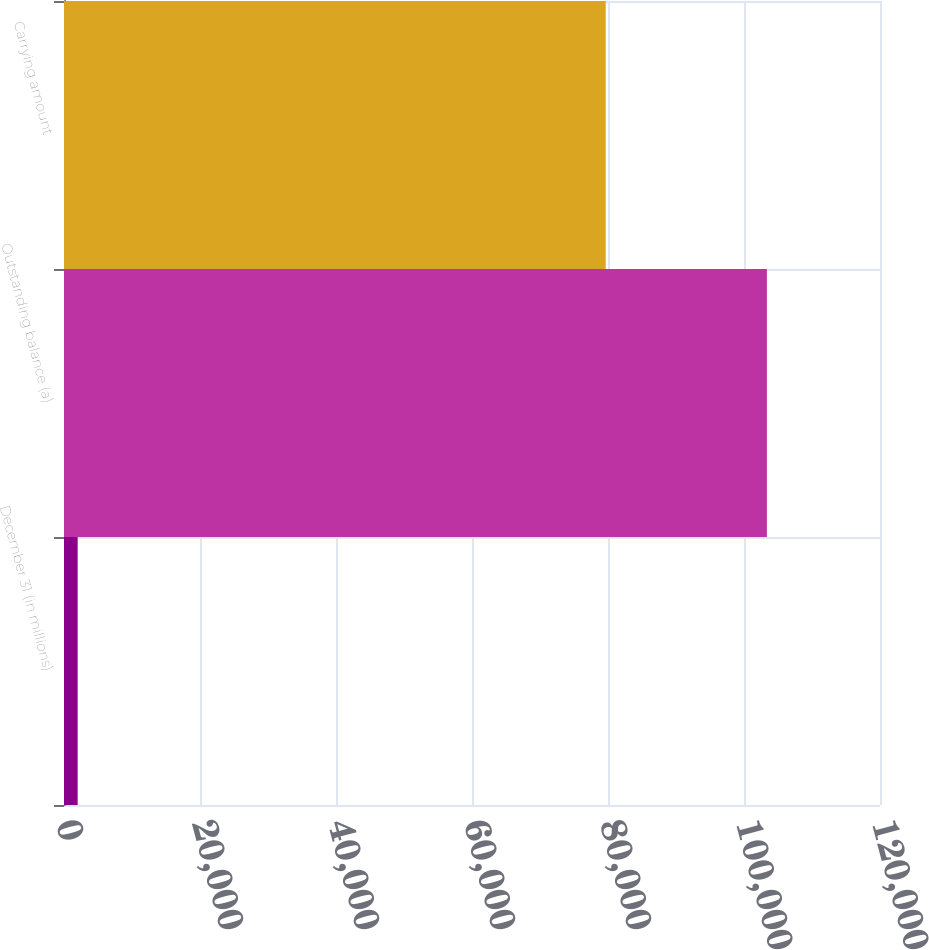<chart> <loc_0><loc_0><loc_500><loc_500><bar_chart><fcel>December 31 (in millions)<fcel>Outstanding balance (a)<fcel>Carrying amount<nl><fcel>2009<fcel>103369<fcel>79664<nl></chart> 